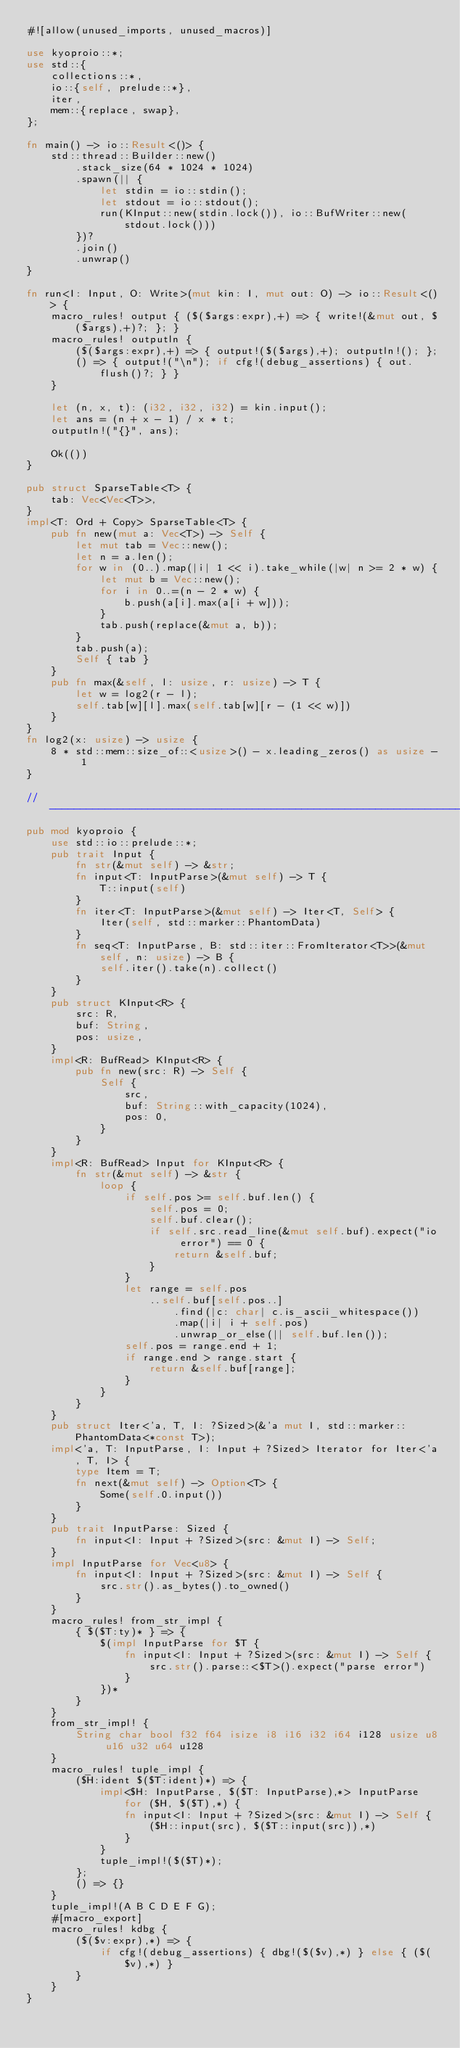Convert code to text. <code><loc_0><loc_0><loc_500><loc_500><_Rust_>#![allow(unused_imports, unused_macros)]

use kyoproio::*;
use std::{
    collections::*,
    io::{self, prelude::*},
    iter,
    mem::{replace, swap},
};

fn main() -> io::Result<()> {
    std::thread::Builder::new()
        .stack_size(64 * 1024 * 1024)
        .spawn(|| {
            let stdin = io::stdin();
            let stdout = io::stdout();
            run(KInput::new(stdin.lock()), io::BufWriter::new(stdout.lock()))
        })?
        .join()
        .unwrap()
}

fn run<I: Input, O: Write>(mut kin: I, mut out: O) -> io::Result<()> {
    macro_rules! output { ($($args:expr),+) => { write!(&mut out, $($args),+)?; }; }
    macro_rules! outputln {
        ($($args:expr),+) => { output!($($args),+); outputln!(); };
        () => { output!("\n"); if cfg!(debug_assertions) { out.flush()?; } }
    }

    let (n, x, t): (i32, i32, i32) = kin.input();
    let ans = (n + x - 1) / x * t;
    outputln!("{}", ans);

    Ok(())
}

pub struct SparseTable<T> {
    tab: Vec<Vec<T>>,
}
impl<T: Ord + Copy> SparseTable<T> {
    pub fn new(mut a: Vec<T>) -> Self {
        let mut tab = Vec::new();
        let n = a.len();
        for w in (0..).map(|i| 1 << i).take_while(|w| n >= 2 * w) {
            let mut b = Vec::new();
            for i in 0..=(n - 2 * w) {
                b.push(a[i].max(a[i + w]));
            }
            tab.push(replace(&mut a, b));
        }
        tab.push(a);
        Self { tab }
    }
    pub fn max(&self, l: usize, r: usize) -> T {
        let w = log2(r - l);
        self.tab[w][l].max(self.tab[w][r - (1 << w)])
    }
}
fn log2(x: usize) -> usize {
    8 * std::mem::size_of::<usize>() - x.leading_zeros() as usize - 1
}

// -----------------------------------------------------------------------------
pub mod kyoproio {
    use std::io::prelude::*;
    pub trait Input {
        fn str(&mut self) -> &str;
        fn input<T: InputParse>(&mut self) -> T {
            T::input(self)
        }
        fn iter<T: InputParse>(&mut self) -> Iter<T, Self> {
            Iter(self, std::marker::PhantomData)
        }
        fn seq<T: InputParse, B: std::iter::FromIterator<T>>(&mut self, n: usize) -> B {
            self.iter().take(n).collect()
        }
    }
    pub struct KInput<R> {
        src: R,
        buf: String,
        pos: usize,
    }
    impl<R: BufRead> KInput<R> {
        pub fn new(src: R) -> Self {
            Self {
                src,
                buf: String::with_capacity(1024),
                pos: 0,
            }
        }
    }
    impl<R: BufRead> Input for KInput<R> {
        fn str(&mut self) -> &str {
            loop {
                if self.pos >= self.buf.len() {
                    self.pos = 0;
                    self.buf.clear();
                    if self.src.read_line(&mut self.buf).expect("io error") == 0 {
                        return &self.buf;
                    }
                }
                let range = self.pos
                    ..self.buf[self.pos..]
                        .find(|c: char| c.is_ascii_whitespace())
                        .map(|i| i + self.pos)
                        .unwrap_or_else(|| self.buf.len());
                self.pos = range.end + 1;
                if range.end > range.start {
                    return &self.buf[range];
                }
            }
        }
    }
    pub struct Iter<'a, T, I: ?Sized>(&'a mut I, std::marker::PhantomData<*const T>);
    impl<'a, T: InputParse, I: Input + ?Sized> Iterator for Iter<'a, T, I> {
        type Item = T;
        fn next(&mut self) -> Option<T> {
            Some(self.0.input())
        }
    }
    pub trait InputParse: Sized {
        fn input<I: Input + ?Sized>(src: &mut I) -> Self;
    }
    impl InputParse for Vec<u8> {
        fn input<I: Input + ?Sized>(src: &mut I) -> Self {
            src.str().as_bytes().to_owned()
        }
    }
    macro_rules! from_str_impl {
        { $($T:ty)* } => {
            $(impl InputParse for $T {
                fn input<I: Input + ?Sized>(src: &mut I) -> Self {
                    src.str().parse::<$T>().expect("parse error")
                }
            })*
        }
    }
    from_str_impl! {
        String char bool f32 f64 isize i8 i16 i32 i64 i128 usize u8 u16 u32 u64 u128
    }
    macro_rules! tuple_impl {
        ($H:ident $($T:ident)*) => {
            impl<$H: InputParse, $($T: InputParse),*> InputParse for ($H, $($T),*) {
                fn input<I: Input + ?Sized>(src: &mut I) -> Self {
                    ($H::input(src), $($T::input(src)),*)
                }
            }
            tuple_impl!($($T)*);
        };
        () => {}
    }
    tuple_impl!(A B C D E F G);
    #[macro_export]
    macro_rules! kdbg {
        ($($v:expr),*) => {
            if cfg!(debug_assertions) { dbg!($($v),*) } else { ($($v),*) }
        }
    }
}
</code> 